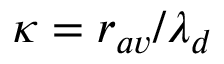<formula> <loc_0><loc_0><loc_500><loc_500>\kappa = r _ { a v } / \lambda _ { d }</formula> 